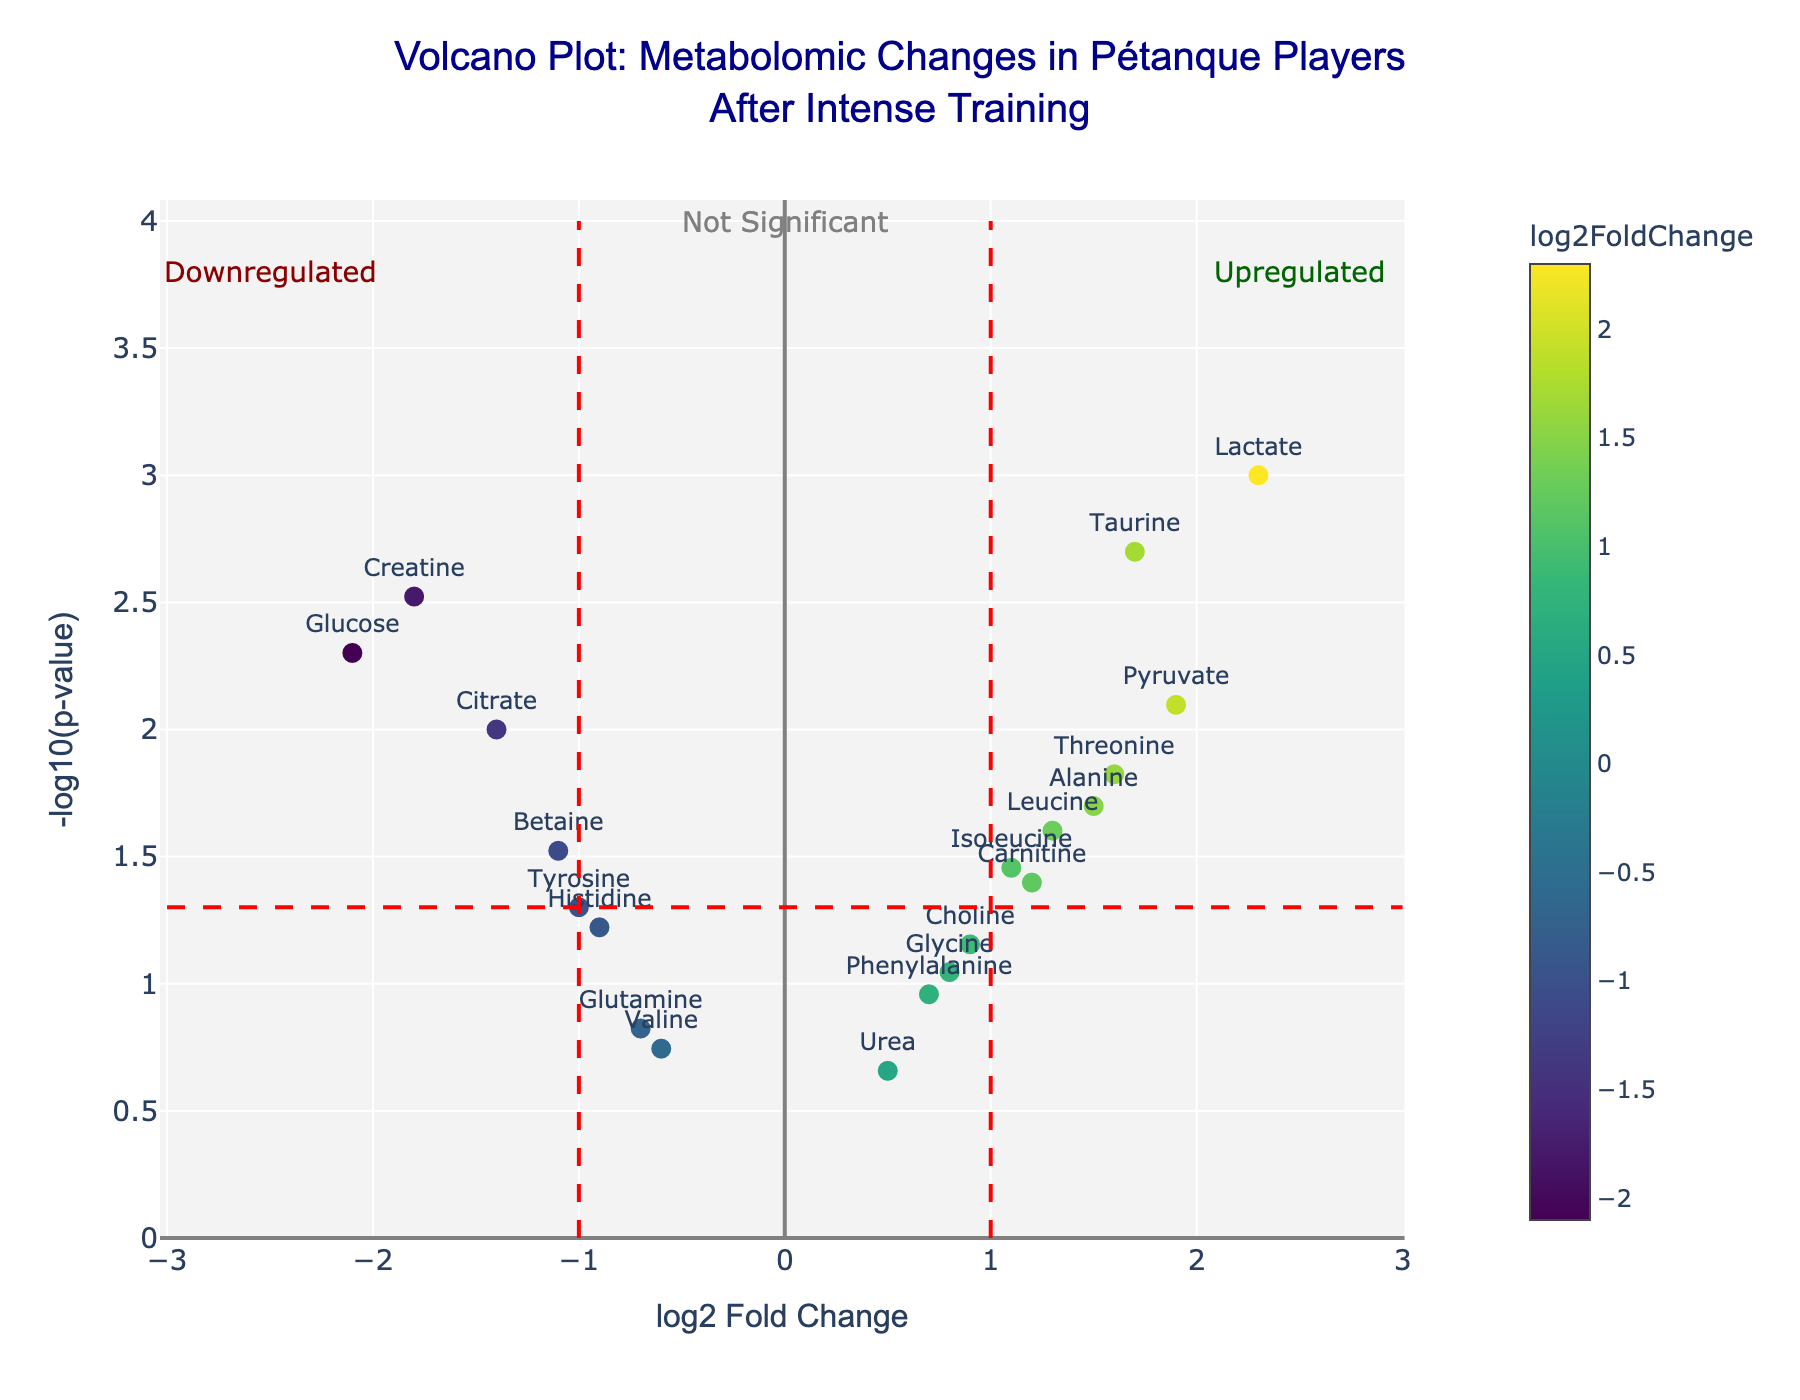What is the title of the volcano plot? The title is located at the top of the figure in a prominent position. It typically provides a brief summary of what the plot represents.
Answer: Volcano Plot: Metabolomic Changes in Pétanque Players After Intense Training What does the x-axis represent? The x-axis represents the "log2 Fold Change," which indicates the ratio of metabolite concentrations after training relative to before training on a log2 scale.
Answer: log2 Fold Change What does the y-axis represent? The y-axis represents the "-log10(p-value)," which indicates the statistical significance of the changes in metabolite concentrations. A higher value denotes more significant changes.
Answer: -log10(p-value) How many metabolites have a log2 Fold Change greater than 1 and a -log10(p-value) greater than 1.3? To answer this, we look for points with an x-axis value greater than 1 and a y-axis value greater than 1.3. There are five points meeting these criteria: Lactate, Alanine, Pyruvate, Taurine, and Threonine.
Answer: 5 Which metabolite has the highest log2 Fold Change and what is its p-value? The metabolite with the highest log2 Fold Change is at the far right of the plot. Lactate has the highest log2 Fold Change of 2.3. Its p-value can be found by hovering over or checking the corresponding hovertext in the plot, which is 0.001.
Answer: Lactate, 0.001 Which metabolite is almost significant with a -log10(p-value) just below 1.3 and a positive log2 Fold Change? Identifying the metabolite involves finding the one with a y-axis value just below 1.3 and a positive x-axis value. Choline fits this description with a log2 Fold Change of 0.9 and a p-value of 0.07.
Answer: Choline What is the median -log10(p-value) of all metabolites in the plot? To find the median, we first calculate the -log10(p-value) for all data points and then find the middle value in the ordered list. The values are: 3, 2.52, 2.40, 2.39, 2.22, 1.7, 1.52, 1.3, 1.26, 1.1, 0.83, 0.79, 0.68, 0.52, 0.38, 0.25, 0.23, 0.18, 0.12. The median is the 10th value, which is -log10(0.06).
Answer: 1.22 Compared to Carnitine, does Alanine show more or less significant changes? Comparing their -log10(p-value) values, Alanine has a -log10(p-value) of 1.70, and Carnitine has 1.4. Thus, Alanine shows more significant changes.
Answer: More significant What does the red horizontal line in the plot represent? The red horizontal line represents the p-value threshold of 0.05, which translates to a -log10(p-value) of 1.3. Metabolites above this line are considered statistically significant.
Answer: p-value threshold Which metabolite shows the highest level of downregulation? The metabolite with the most negative log2 Fold Change value represents the highest level of downregulation. Glucose at -2.1 demonstrates the highest level of downregulation.
Answer: Glucose 